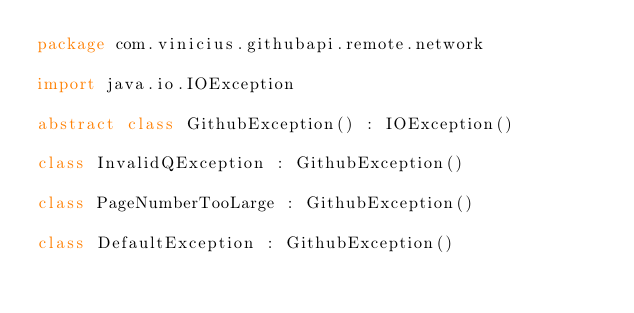Convert code to text. <code><loc_0><loc_0><loc_500><loc_500><_Kotlin_>package com.vinicius.githubapi.remote.network

import java.io.IOException

abstract class GithubException() : IOException()

class InvalidQException : GithubException()

class PageNumberTooLarge : GithubException()

class DefaultException : GithubException()</code> 